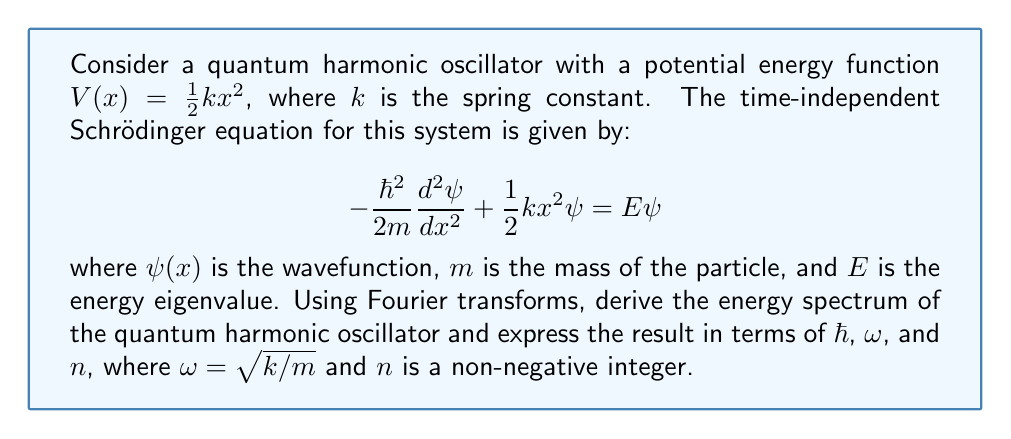Could you help me with this problem? To solve this problem using Fourier transforms, we'll follow these steps:

1) First, let's take the Fourier transform of both sides of the Schrödinger equation. The Fourier transform of $\psi(x)$ is defined as:

   $$\tilde{\psi}(p) = \frac{1}{\sqrt{2\pi\hbar}}\int_{-\infty}^{\infty} \psi(x)e^{-ipx/\hbar}dx$$

2) The Fourier transform of the second derivative term is:

   $$\mathcal{F}\left[-\frac{\hbar^2}{2m}\frac{d^2\psi}{dx^2}\right] = \frac{p^2}{2m}\tilde{\psi}(p)$$

3) For the potential energy term, we use the property that multiplication by $x^2$ in real space becomes the second derivative with respect to $p$ in momentum space:

   $$\mathcal{F}\left[\frac{1}{2}kx^2\psi(x)\right] = -\frac{\hbar^2k}{2}\frac{d^2\tilde{\psi}}{dp^2}$$

4) The Fourier transformed Schrödinger equation becomes:

   $$\frac{p^2}{2m}\tilde{\psi}(p) - \frac{\hbar^2k}{2}\frac{d^2\tilde{\psi}}{dp^2} = E\tilde{\psi}(p)$$

5) Rearranging the terms:

   $$\frac{d^2\tilde{\psi}}{dp^2} + \left(\frac{2E}{\hbar^2k} - \frac{p^2}{m\hbar^2k}\right)\tilde{\psi}(p) = 0$$

6) This is a second-order differential equation. Let's substitute $\omega = \sqrt{k/m}$ and $u = p/\sqrt{m\hbar\omega}$:

   $$\frac{d^2\tilde{\psi}}{du^2} + \left(\frac{2E}{\hbar\omega} - u^2\right)\tilde{\psi}(u) = 0$$

7) This is the differential equation for the Hermite polynomials. The solutions exist only when:

   $$\frac{2E}{\hbar\omega} = 2n + 1$$

   where $n$ is a non-negative integer.

8) Solving for $E$:

   $$E = \hbar\omega(n + \frac{1}{2})$$

This is the energy spectrum of the quantum harmonic oscillator.
Answer: The energy spectrum of the quantum harmonic oscillator is given by:

$$E_n = \hbar\omega(n + \frac{1}{2})$$

where $n$ is a non-negative integer, $\hbar$ is the reduced Planck constant, and $\omega = \sqrt{k/m}$ is the angular frequency of the oscillator. 